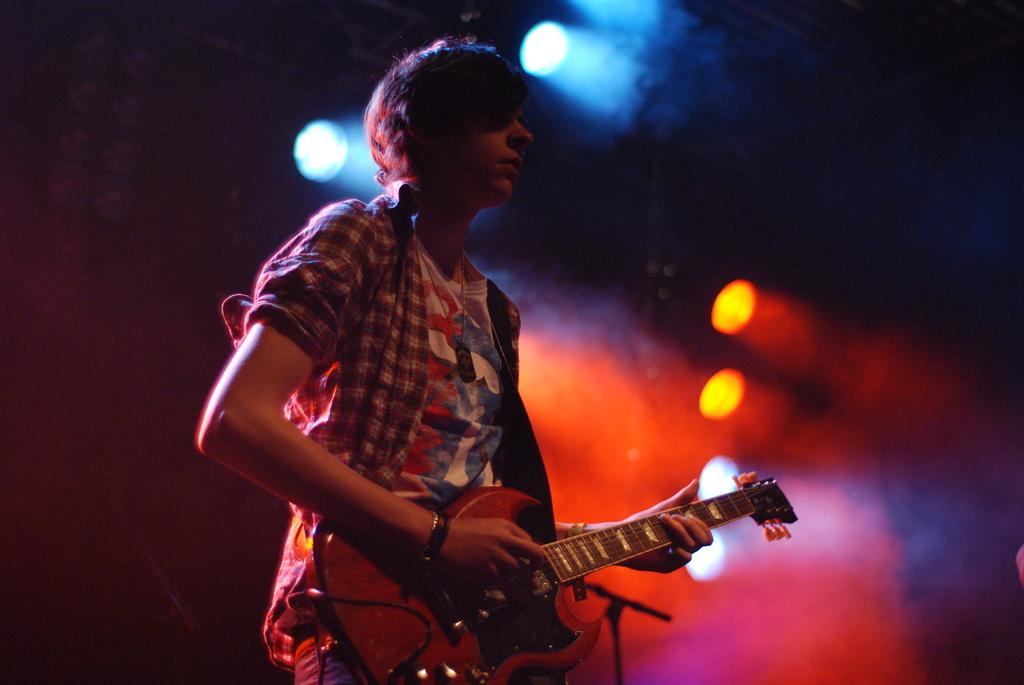What is the main subject of the image? There is a man in the image. What is the man doing in the image? The man is standing in the image. What object is the man holding in the image? The man is holding a guitar in the image. What can be seen in the background of the image? There are lights visible in the background of the image. What type of wren is perched on the man's shoulder in the image? There is no wren present in the image; the man is holding a guitar, not a bird. 